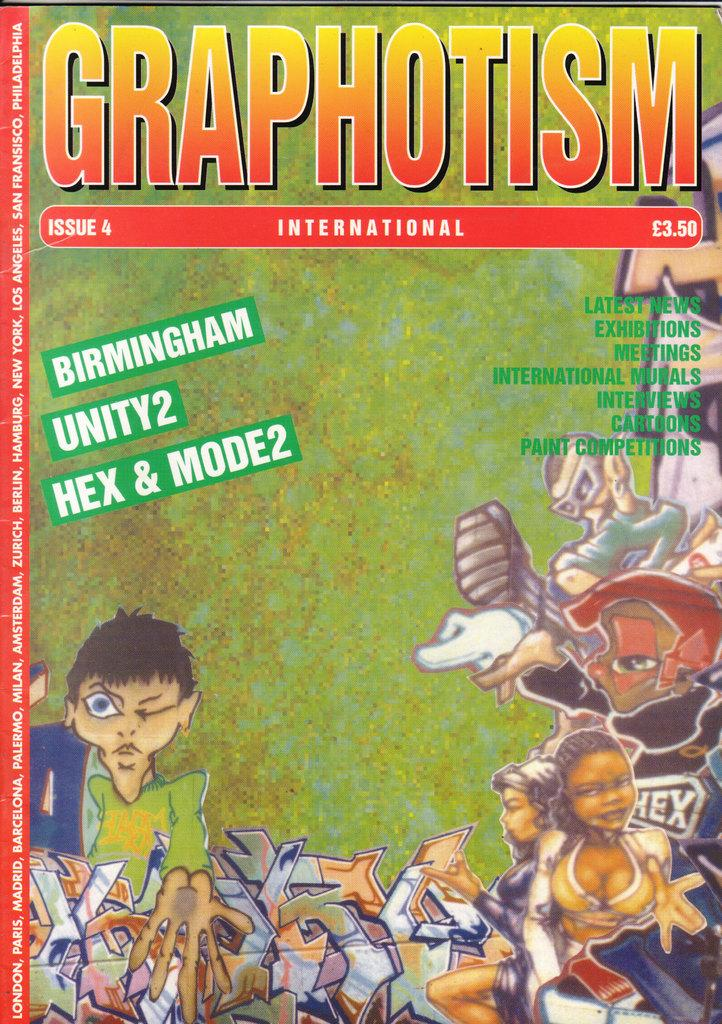What type of visual is the image in question? The image is a poster. What kind of characters are depicted on the poster? There are cartoon images of some persons on the poster. Are there any words or phrases on the poster? Yes, there is text on the poster. What type of education is being offered at the hospital depicted in the poster? There is no hospital depicted in the poster; it features cartoon images of persons and text. 